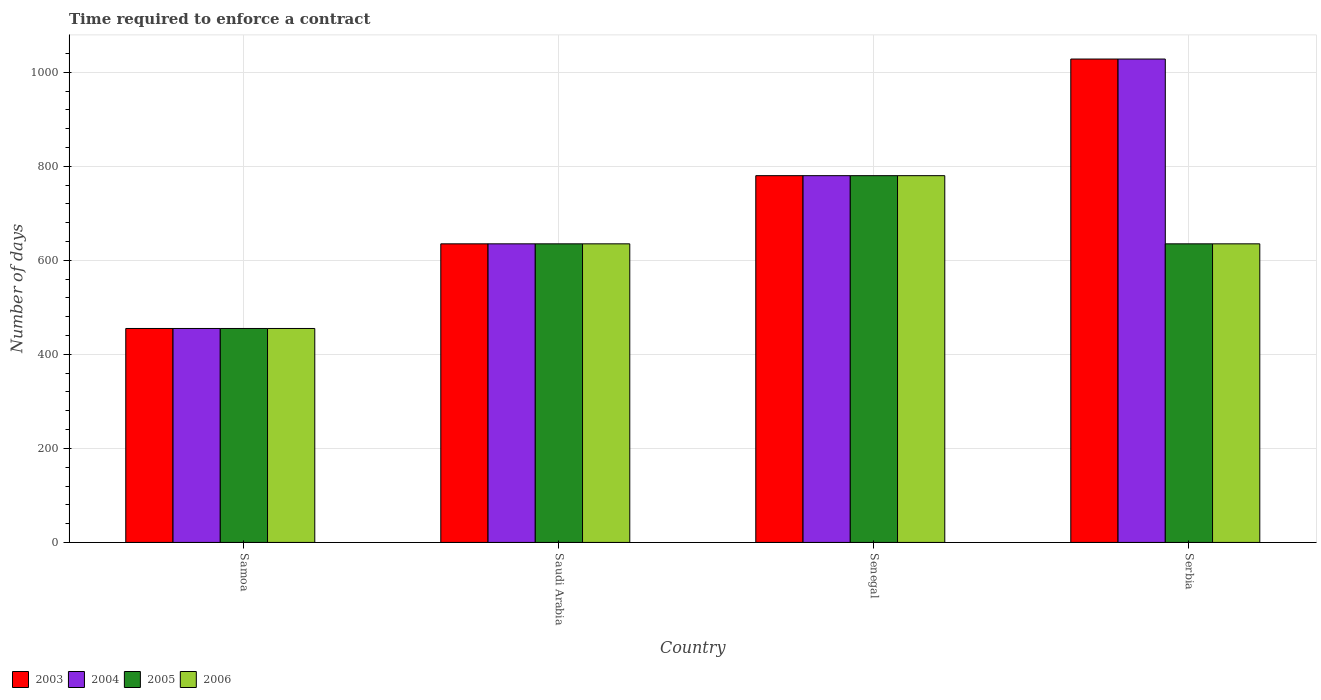Are the number of bars on each tick of the X-axis equal?
Give a very brief answer. Yes. What is the label of the 2nd group of bars from the left?
Make the answer very short. Saudi Arabia. In how many cases, is the number of bars for a given country not equal to the number of legend labels?
Provide a succinct answer. 0. What is the number of days required to enforce a contract in 2003 in Serbia?
Your answer should be compact. 1028. Across all countries, what is the maximum number of days required to enforce a contract in 2003?
Offer a terse response. 1028. Across all countries, what is the minimum number of days required to enforce a contract in 2004?
Offer a terse response. 455. In which country was the number of days required to enforce a contract in 2004 maximum?
Offer a terse response. Serbia. In which country was the number of days required to enforce a contract in 2003 minimum?
Keep it short and to the point. Samoa. What is the total number of days required to enforce a contract in 2003 in the graph?
Your answer should be compact. 2898. What is the difference between the number of days required to enforce a contract in 2003 in Samoa and that in Serbia?
Your answer should be compact. -573. What is the difference between the number of days required to enforce a contract in 2004 in Samoa and the number of days required to enforce a contract in 2005 in Saudi Arabia?
Your answer should be compact. -180. What is the average number of days required to enforce a contract in 2006 per country?
Your answer should be very brief. 626.25. What is the difference between the number of days required to enforce a contract of/in 2005 and number of days required to enforce a contract of/in 2004 in Samoa?
Ensure brevity in your answer.  0. What is the ratio of the number of days required to enforce a contract in 2006 in Samoa to that in Serbia?
Your answer should be very brief. 0.72. Is the difference between the number of days required to enforce a contract in 2005 in Samoa and Saudi Arabia greater than the difference between the number of days required to enforce a contract in 2004 in Samoa and Saudi Arabia?
Provide a short and direct response. No. What is the difference between the highest and the second highest number of days required to enforce a contract in 2005?
Provide a succinct answer. -145. What is the difference between the highest and the lowest number of days required to enforce a contract in 2005?
Your answer should be very brief. 325. In how many countries, is the number of days required to enforce a contract in 2003 greater than the average number of days required to enforce a contract in 2003 taken over all countries?
Keep it short and to the point. 2. Is it the case that in every country, the sum of the number of days required to enforce a contract in 2005 and number of days required to enforce a contract in 2004 is greater than the sum of number of days required to enforce a contract in 2006 and number of days required to enforce a contract in 2003?
Your response must be concise. No. Is it the case that in every country, the sum of the number of days required to enforce a contract in 2006 and number of days required to enforce a contract in 2005 is greater than the number of days required to enforce a contract in 2003?
Your answer should be compact. Yes. How many countries are there in the graph?
Offer a very short reply. 4. Are the values on the major ticks of Y-axis written in scientific E-notation?
Offer a terse response. No. Does the graph contain any zero values?
Your answer should be compact. No. Does the graph contain grids?
Your answer should be very brief. Yes. How many legend labels are there?
Provide a succinct answer. 4. What is the title of the graph?
Keep it short and to the point. Time required to enforce a contract. What is the label or title of the Y-axis?
Keep it short and to the point. Number of days. What is the Number of days in 2003 in Samoa?
Ensure brevity in your answer.  455. What is the Number of days of 2004 in Samoa?
Make the answer very short. 455. What is the Number of days of 2005 in Samoa?
Your answer should be compact. 455. What is the Number of days in 2006 in Samoa?
Ensure brevity in your answer.  455. What is the Number of days in 2003 in Saudi Arabia?
Offer a terse response. 635. What is the Number of days in 2004 in Saudi Arabia?
Give a very brief answer. 635. What is the Number of days in 2005 in Saudi Arabia?
Keep it short and to the point. 635. What is the Number of days of 2006 in Saudi Arabia?
Offer a very short reply. 635. What is the Number of days in 2003 in Senegal?
Provide a succinct answer. 780. What is the Number of days of 2004 in Senegal?
Your answer should be compact. 780. What is the Number of days in 2005 in Senegal?
Ensure brevity in your answer.  780. What is the Number of days in 2006 in Senegal?
Your response must be concise. 780. What is the Number of days of 2003 in Serbia?
Provide a short and direct response. 1028. What is the Number of days in 2004 in Serbia?
Your answer should be very brief. 1028. What is the Number of days in 2005 in Serbia?
Provide a succinct answer. 635. What is the Number of days of 2006 in Serbia?
Ensure brevity in your answer.  635. Across all countries, what is the maximum Number of days of 2003?
Keep it short and to the point. 1028. Across all countries, what is the maximum Number of days in 2004?
Provide a short and direct response. 1028. Across all countries, what is the maximum Number of days in 2005?
Provide a short and direct response. 780. Across all countries, what is the maximum Number of days in 2006?
Ensure brevity in your answer.  780. Across all countries, what is the minimum Number of days of 2003?
Offer a very short reply. 455. Across all countries, what is the minimum Number of days of 2004?
Offer a very short reply. 455. Across all countries, what is the minimum Number of days in 2005?
Your response must be concise. 455. Across all countries, what is the minimum Number of days of 2006?
Ensure brevity in your answer.  455. What is the total Number of days of 2003 in the graph?
Make the answer very short. 2898. What is the total Number of days in 2004 in the graph?
Make the answer very short. 2898. What is the total Number of days in 2005 in the graph?
Keep it short and to the point. 2505. What is the total Number of days of 2006 in the graph?
Keep it short and to the point. 2505. What is the difference between the Number of days in 2003 in Samoa and that in Saudi Arabia?
Your response must be concise. -180. What is the difference between the Number of days in 2004 in Samoa and that in Saudi Arabia?
Give a very brief answer. -180. What is the difference between the Number of days of 2005 in Samoa and that in Saudi Arabia?
Provide a short and direct response. -180. What is the difference between the Number of days in 2006 in Samoa and that in Saudi Arabia?
Offer a terse response. -180. What is the difference between the Number of days of 2003 in Samoa and that in Senegal?
Provide a short and direct response. -325. What is the difference between the Number of days in 2004 in Samoa and that in Senegal?
Your answer should be very brief. -325. What is the difference between the Number of days of 2005 in Samoa and that in Senegal?
Offer a terse response. -325. What is the difference between the Number of days of 2006 in Samoa and that in Senegal?
Make the answer very short. -325. What is the difference between the Number of days in 2003 in Samoa and that in Serbia?
Your response must be concise. -573. What is the difference between the Number of days in 2004 in Samoa and that in Serbia?
Ensure brevity in your answer.  -573. What is the difference between the Number of days in 2005 in Samoa and that in Serbia?
Your response must be concise. -180. What is the difference between the Number of days in 2006 in Samoa and that in Serbia?
Your answer should be very brief. -180. What is the difference between the Number of days of 2003 in Saudi Arabia and that in Senegal?
Ensure brevity in your answer.  -145. What is the difference between the Number of days of 2004 in Saudi Arabia and that in Senegal?
Give a very brief answer. -145. What is the difference between the Number of days in 2005 in Saudi Arabia and that in Senegal?
Your response must be concise. -145. What is the difference between the Number of days in 2006 in Saudi Arabia and that in Senegal?
Provide a short and direct response. -145. What is the difference between the Number of days of 2003 in Saudi Arabia and that in Serbia?
Provide a succinct answer. -393. What is the difference between the Number of days of 2004 in Saudi Arabia and that in Serbia?
Offer a very short reply. -393. What is the difference between the Number of days in 2003 in Senegal and that in Serbia?
Offer a very short reply. -248. What is the difference between the Number of days in 2004 in Senegal and that in Serbia?
Give a very brief answer. -248. What is the difference between the Number of days in 2005 in Senegal and that in Serbia?
Your answer should be very brief. 145. What is the difference between the Number of days in 2006 in Senegal and that in Serbia?
Ensure brevity in your answer.  145. What is the difference between the Number of days of 2003 in Samoa and the Number of days of 2004 in Saudi Arabia?
Make the answer very short. -180. What is the difference between the Number of days in 2003 in Samoa and the Number of days in 2005 in Saudi Arabia?
Your answer should be compact. -180. What is the difference between the Number of days of 2003 in Samoa and the Number of days of 2006 in Saudi Arabia?
Provide a short and direct response. -180. What is the difference between the Number of days in 2004 in Samoa and the Number of days in 2005 in Saudi Arabia?
Provide a short and direct response. -180. What is the difference between the Number of days of 2004 in Samoa and the Number of days of 2006 in Saudi Arabia?
Provide a succinct answer. -180. What is the difference between the Number of days in 2005 in Samoa and the Number of days in 2006 in Saudi Arabia?
Your answer should be compact. -180. What is the difference between the Number of days in 2003 in Samoa and the Number of days in 2004 in Senegal?
Offer a terse response. -325. What is the difference between the Number of days of 2003 in Samoa and the Number of days of 2005 in Senegal?
Your response must be concise. -325. What is the difference between the Number of days of 2003 in Samoa and the Number of days of 2006 in Senegal?
Offer a terse response. -325. What is the difference between the Number of days in 2004 in Samoa and the Number of days in 2005 in Senegal?
Ensure brevity in your answer.  -325. What is the difference between the Number of days of 2004 in Samoa and the Number of days of 2006 in Senegal?
Provide a short and direct response. -325. What is the difference between the Number of days in 2005 in Samoa and the Number of days in 2006 in Senegal?
Offer a terse response. -325. What is the difference between the Number of days of 2003 in Samoa and the Number of days of 2004 in Serbia?
Your response must be concise. -573. What is the difference between the Number of days of 2003 in Samoa and the Number of days of 2005 in Serbia?
Provide a succinct answer. -180. What is the difference between the Number of days in 2003 in Samoa and the Number of days in 2006 in Serbia?
Make the answer very short. -180. What is the difference between the Number of days of 2004 in Samoa and the Number of days of 2005 in Serbia?
Ensure brevity in your answer.  -180. What is the difference between the Number of days of 2004 in Samoa and the Number of days of 2006 in Serbia?
Make the answer very short. -180. What is the difference between the Number of days of 2005 in Samoa and the Number of days of 2006 in Serbia?
Provide a succinct answer. -180. What is the difference between the Number of days of 2003 in Saudi Arabia and the Number of days of 2004 in Senegal?
Your response must be concise. -145. What is the difference between the Number of days of 2003 in Saudi Arabia and the Number of days of 2005 in Senegal?
Your response must be concise. -145. What is the difference between the Number of days in 2003 in Saudi Arabia and the Number of days in 2006 in Senegal?
Offer a terse response. -145. What is the difference between the Number of days of 2004 in Saudi Arabia and the Number of days of 2005 in Senegal?
Make the answer very short. -145. What is the difference between the Number of days in 2004 in Saudi Arabia and the Number of days in 2006 in Senegal?
Give a very brief answer. -145. What is the difference between the Number of days of 2005 in Saudi Arabia and the Number of days of 2006 in Senegal?
Your answer should be very brief. -145. What is the difference between the Number of days in 2003 in Saudi Arabia and the Number of days in 2004 in Serbia?
Make the answer very short. -393. What is the difference between the Number of days of 2003 in Saudi Arabia and the Number of days of 2005 in Serbia?
Your answer should be compact. 0. What is the difference between the Number of days of 2003 in Saudi Arabia and the Number of days of 2006 in Serbia?
Offer a very short reply. 0. What is the difference between the Number of days of 2004 in Saudi Arabia and the Number of days of 2005 in Serbia?
Your response must be concise. 0. What is the difference between the Number of days of 2004 in Saudi Arabia and the Number of days of 2006 in Serbia?
Keep it short and to the point. 0. What is the difference between the Number of days in 2003 in Senegal and the Number of days in 2004 in Serbia?
Ensure brevity in your answer.  -248. What is the difference between the Number of days in 2003 in Senegal and the Number of days in 2005 in Serbia?
Your response must be concise. 145. What is the difference between the Number of days of 2003 in Senegal and the Number of days of 2006 in Serbia?
Make the answer very short. 145. What is the difference between the Number of days of 2004 in Senegal and the Number of days of 2005 in Serbia?
Give a very brief answer. 145. What is the difference between the Number of days in 2004 in Senegal and the Number of days in 2006 in Serbia?
Make the answer very short. 145. What is the difference between the Number of days of 2005 in Senegal and the Number of days of 2006 in Serbia?
Provide a short and direct response. 145. What is the average Number of days of 2003 per country?
Make the answer very short. 724.5. What is the average Number of days in 2004 per country?
Offer a very short reply. 724.5. What is the average Number of days of 2005 per country?
Offer a terse response. 626.25. What is the average Number of days in 2006 per country?
Your response must be concise. 626.25. What is the difference between the Number of days in 2003 and Number of days in 2004 in Samoa?
Provide a short and direct response. 0. What is the difference between the Number of days of 2003 and Number of days of 2005 in Samoa?
Offer a terse response. 0. What is the difference between the Number of days in 2004 and Number of days in 2005 in Samoa?
Your answer should be very brief. 0. What is the difference between the Number of days of 2005 and Number of days of 2006 in Samoa?
Provide a succinct answer. 0. What is the difference between the Number of days in 2003 and Number of days in 2004 in Saudi Arabia?
Ensure brevity in your answer.  0. What is the difference between the Number of days of 2003 and Number of days of 2005 in Saudi Arabia?
Your answer should be compact. 0. What is the difference between the Number of days in 2004 and Number of days in 2005 in Saudi Arabia?
Your response must be concise. 0. What is the difference between the Number of days in 2005 and Number of days in 2006 in Saudi Arabia?
Offer a terse response. 0. What is the difference between the Number of days in 2003 and Number of days in 2005 in Senegal?
Your answer should be very brief. 0. What is the difference between the Number of days of 2003 and Number of days of 2006 in Senegal?
Offer a terse response. 0. What is the difference between the Number of days of 2004 and Number of days of 2005 in Senegal?
Your answer should be compact. 0. What is the difference between the Number of days in 2004 and Number of days in 2006 in Senegal?
Your response must be concise. 0. What is the difference between the Number of days of 2005 and Number of days of 2006 in Senegal?
Keep it short and to the point. 0. What is the difference between the Number of days in 2003 and Number of days in 2005 in Serbia?
Ensure brevity in your answer.  393. What is the difference between the Number of days in 2003 and Number of days in 2006 in Serbia?
Offer a terse response. 393. What is the difference between the Number of days of 2004 and Number of days of 2005 in Serbia?
Your answer should be very brief. 393. What is the difference between the Number of days in 2004 and Number of days in 2006 in Serbia?
Offer a terse response. 393. What is the ratio of the Number of days of 2003 in Samoa to that in Saudi Arabia?
Your answer should be very brief. 0.72. What is the ratio of the Number of days in 2004 in Samoa to that in Saudi Arabia?
Ensure brevity in your answer.  0.72. What is the ratio of the Number of days of 2005 in Samoa to that in Saudi Arabia?
Your answer should be very brief. 0.72. What is the ratio of the Number of days in 2006 in Samoa to that in Saudi Arabia?
Make the answer very short. 0.72. What is the ratio of the Number of days of 2003 in Samoa to that in Senegal?
Your response must be concise. 0.58. What is the ratio of the Number of days in 2004 in Samoa to that in Senegal?
Provide a succinct answer. 0.58. What is the ratio of the Number of days of 2005 in Samoa to that in Senegal?
Ensure brevity in your answer.  0.58. What is the ratio of the Number of days of 2006 in Samoa to that in Senegal?
Provide a short and direct response. 0.58. What is the ratio of the Number of days of 2003 in Samoa to that in Serbia?
Ensure brevity in your answer.  0.44. What is the ratio of the Number of days of 2004 in Samoa to that in Serbia?
Keep it short and to the point. 0.44. What is the ratio of the Number of days in 2005 in Samoa to that in Serbia?
Give a very brief answer. 0.72. What is the ratio of the Number of days of 2006 in Samoa to that in Serbia?
Offer a terse response. 0.72. What is the ratio of the Number of days of 2003 in Saudi Arabia to that in Senegal?
Provide a short and direct response. 0.81. What is the ratio of the Number of days of 2004 in Saudi Arabia to that in Senegal?
Provide a succinct answer. 0.81. What is the ratio of the Number of days of 2005 in Saudi Arabia to that in Senegal?
Give a very brief answer. 0.81. What is the ratio of the Number of days in 2006 in Saudi Arabia to that in Senegal?
Offer a very short reply. 0.81. What is the ratio of the Number of days of 2003 in Saudi Arabia to that in Serbia?
Offer a terse response. 0.62. What is the ratio of the Number of days in 2004 in Saudi Arabia to that in Serbia?
Your response must be concise. 0.62. What is the ratio of the Number of days of 2005 in Saudi Arabia to that in Serbia?
Give a very brief answer. 1. What is the ratio of the Number of days of 2006 in Saudi Arabia to that in Serbia?
Make the answer very short. 1. What is the ratio of the Number of days of 2003 in Senegal to that in Serbia?
Your response must be concise. 0.76. What is the ratio of the Number of days of 2004 in Senegal to that in Serbia?
Make the answer very short. 0.76. What is the ratio of the Number of days in 2005 in Senegal to that in Serbia?
Offer a very short reply. 1.23. What is the ratio of the Number of days of 2006 in Senegal to that in Serbia?
Ensure brevity in your answer.  1.23. What is the difference between the highest and the second highest Number of days in 2003?
Provide a succinct answer. 248. What is the difference between the highest and the second highest Number of days of 2004?
Make the answer very short. 248. What is the difference between the highest and the second highest Number of days in 2005?
Your answer should be very brief. 145. What is the difference between the highest and the second highest Number of days of 2006?
Provide a succinct answer. 145. What is the difference between the highest and the lowest Number of days of 2003?
Your answer should be very brief. 573. What is the difference between the highest and the lowest Number of days of 2004?
Keep it short and to the point. 573. What is the difference between the highest and the lowest Number of days in 2005?
Provide a short and direct response. 325. What is the difference between the highest and the lowest Number of days of 2006?
Give a very brief answer. 325. 